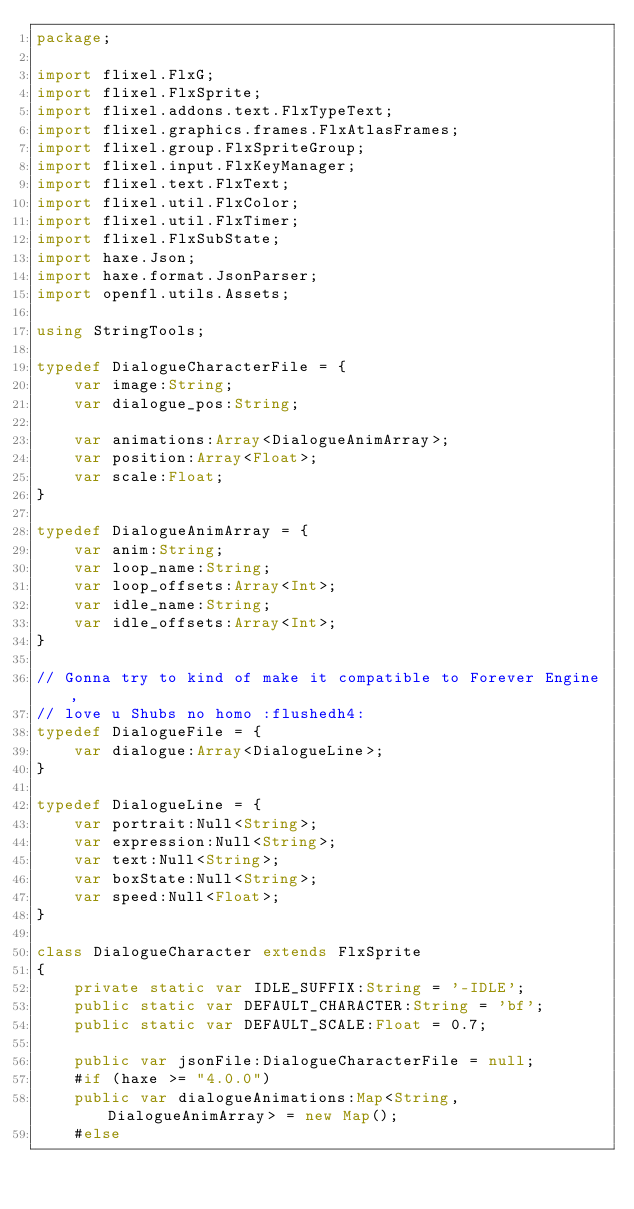<code> <loc_0><loc_0><loc_500><loc_500><_Haxe_>package;

import flixel.FlxG;
import flixel.FlxSprite;
import flixel.addons.text.FlxTypeText;
import flixel.graphics.frames.FlxAtlasFrames;
import flixel.group.FlxSpriteGroup;
import flixel.input.FlxKeyManager;
import flixel.text.FlxText;
import flixel.util.FlxColor;
import flixel.util.FlxTimer;
import flixel.FlxSubState;
import haxe.Json;
import haxe.format.JsonParser;
import openfl.utils.Assets;

using StringTools;

typedef DialogueCharacterFile = {
	var image:String;
	var dialogue_pos:String;

	var animations:Array<DialogueAnimArray>;
	var position:Array<Float>;
	var scale:Float;
}

typedef DialogueAnimArray = {
	var anim:String;
	var loop_name:String;
	var loop_offsets:Array<Int>;
	var idle_name:String;
	var idle_offsets:Array<Int>;
}

// Gonna try to kind of make it compatible to Forever Engine,
// love u Shubs no homo :flushedh4:
typedef DialogueFile = {
	var dialogue:Array<DialogueLine>;
}

typedef DialogueLine = {
	var portrait:Null<String>;
	var expression:Null<String>;
	var text:Null<String>;
	var boxState:Null<String>;
	var speed:Null<Float>;
}

class DialogueCharacter extends FlxSprite
{
	private static var IDLE_SUFFIX:String = '-IDLE';
	public static var DEFAULT_CHARACTER:String = 'bf';
	public static var DEFAULT_SCALE:Float = 0.7;

	public var jsonFile:DialogueCharacterFile = null;
	#if (haxe >= "4.0.0")
	public var dialogueAnimations:Map<String, DialogueAnimArray> = new Map();
	#else</code> 